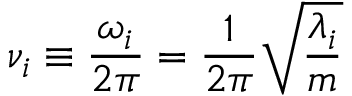Convert formula to latex. <formula><loc_0><loc_0><loc_500><loc_500>\nu _ { i } \equiv \frac { \omega _ { i } } { 2 \pi } = \frac { 1 } { 2 \pi } \sqrt { \frac { \lambda _ { i } } { m } }</formula> 